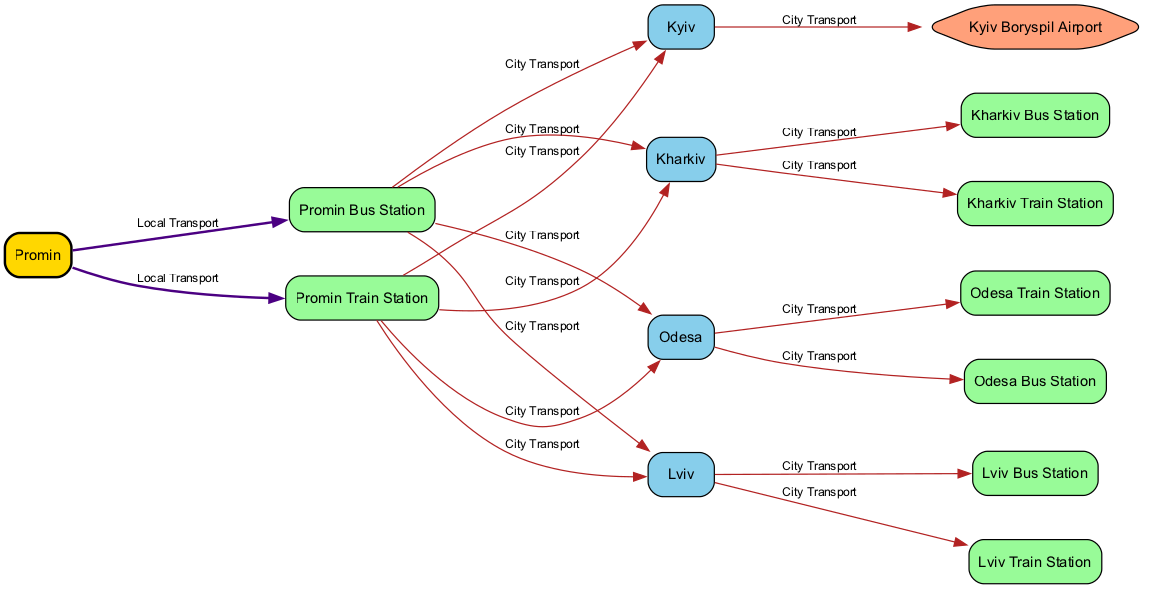What is the label of the node "Promin"? The diagram indicates that the node "Promin" has the label "Promin". This can be found directly by looking at the node identified by "Promin".
Answer: Promin How many nodes are in the diagram? To find the number of nodes, we count each unique node listed in the "nodes" section of the data. There are 14 different nodes, including all cities and stations.
Answer: 14 Which station connects "Promin" to "Kyiv"? The diagram shows that both the "Promin Bus Station" and "Promin Train Station" have direct edges leading to "Kyiv", indicating that both stations can be used to travel to Kyiv from Promin.
Answer: Promin Bus Station or Promin Train Station What color represents "Kyiv Boryspil Airport"? In the diagram, the airport node is distinctly colored in "Light Salmon" based on the specified color coding in the data. Therefore, Kyiv Boryspil Airport is depicted in this color.
Answer: Light Salmon Which city can be reached directly from "Odesa"? The edges indicate that "Odesa" has direct connections to "Bus Station Odesa" and "Train Station Odesa". From these stations, the path leads to various destinations, but the question focuses on the direct connection to the next step, which is defined by the direct routes indicated. The primary cities directly listed from Odesa are Lviv and Kyiv.
Answer: Lviv or Kyiv How many edges connect Promin to transportation nodes? Counting the edges that originate from "Promin", we see that there are two edges: one connecting to "Bus Station Promin" and another to "Train Station Promin". Therefore, the total is two direct connections.
Answer: 2 Does "Kharkiv" have a bus station? The diagram shows that there is a node labeled "Kharkiv Bus Station", which confirms its existence. By checking the edges, it is apparent that Kharkiv can be reached by bus.
Answer: Yes What is the connection type for routes from "Train Station Promin"? The edges originating from "Train Station Promin" show that they lead to "Kyiv", "Lviv", "Odesa", and "Kharkiv". Each of these is an arrival route marked distinctly in the diagram as "Arrival", which outlines the connections available from this station.
Answer: Arrival Which mode of transport directly connects Promin to Lviv? The edge connecting "Promin" to "Lviv" goes through "Bus Station Promin". This station serves as a transit point to reach Lviv, indicating the local transport used.
Answer: Local Transport 